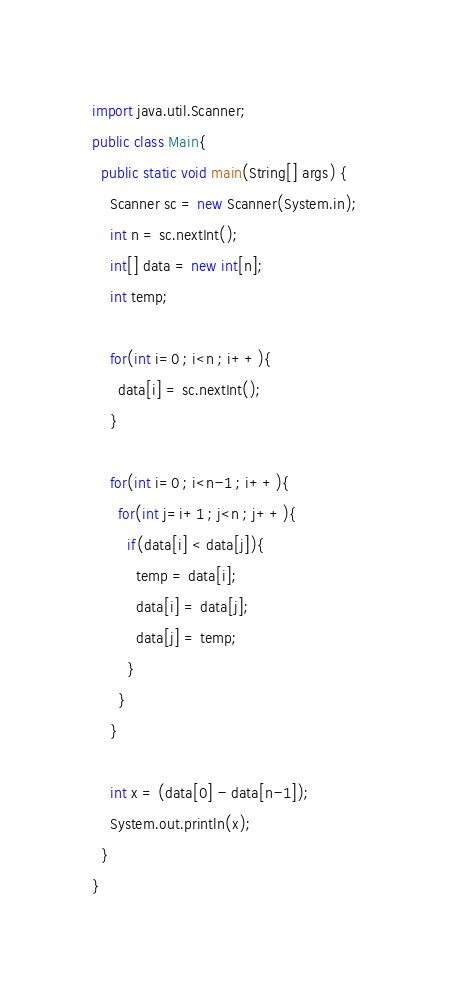<code> <loc_0><loc_0><loc_500><loc_500><_Java_>import java.util.Scanner;
public class Main{
  public static void main(String[] args) {
    Scanner sc = new Scanner(System.in);
    int n = sc.nextInt();
    int[] data = new int[n];
    int temp;

    for(int i=0 ; i<n ; i++){
      data[i] = sc.nextInt();
    }

    for(int i=0 ; i<n-1 ; i++){
      for(int j=i+1 ; j<n ; j++){
        if(data[i] < data[j]){
          temp = data[i];
          data[i] = data[j];
          data[j] = temp;
        }
      }
    }

    int x = (data[0] - data[n-1]);
    System.out.println(x);
  }
}
</code> 